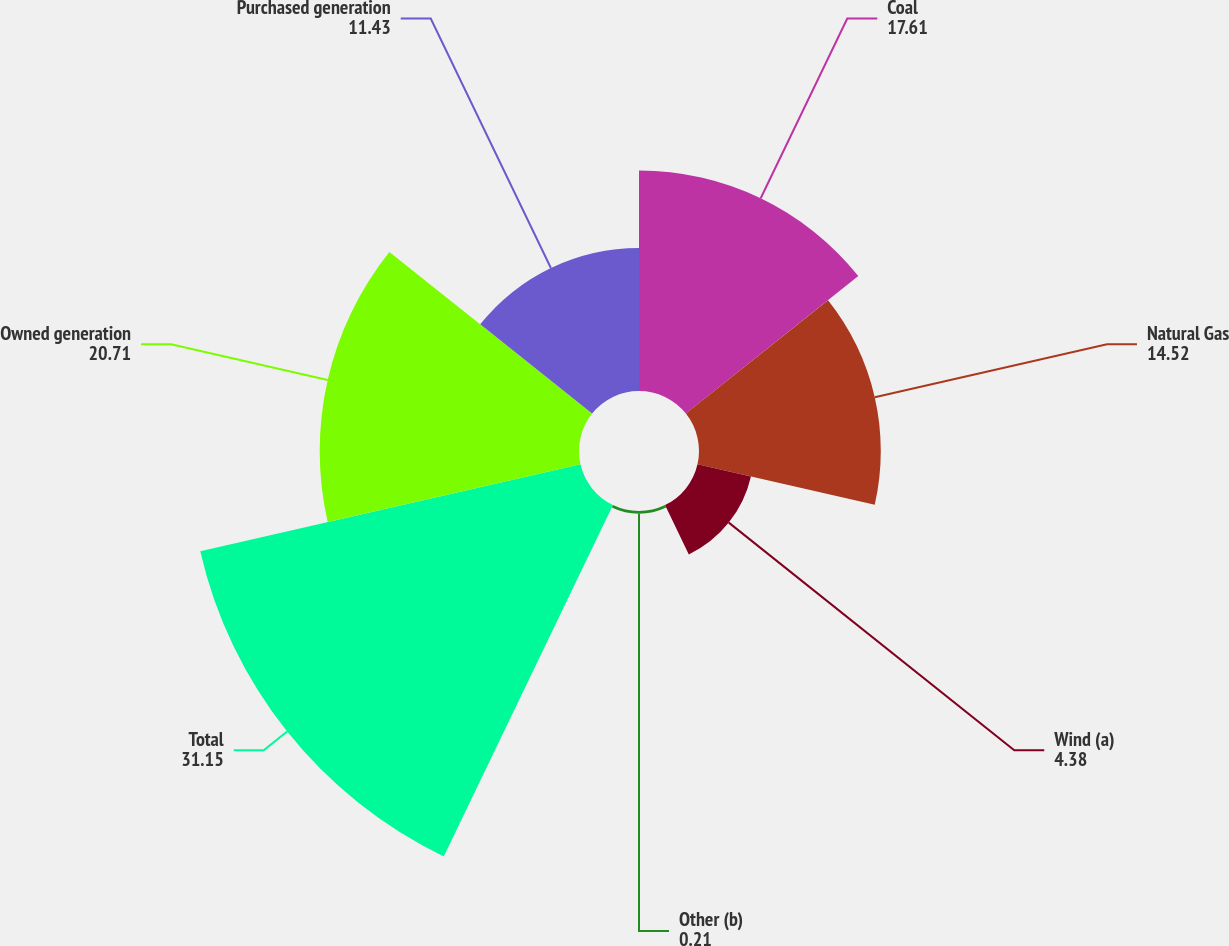Convert chart. <chart><loc_0><loc_0><loc_500><loc_500><pie_chart><fcel>Coal<fcel>Natural Gas<fcel>Wind (a)<fcel>Other (b)<fcel>Total<fcel>Owned generation<fcel>Purchased generation<nl><fcel>17.61%<fcel>14.52%<fcel>4.38%<fcel>0.21%<fcel>31.15%<fcel>20.71%<fcel>11.43%<nl></chart> 